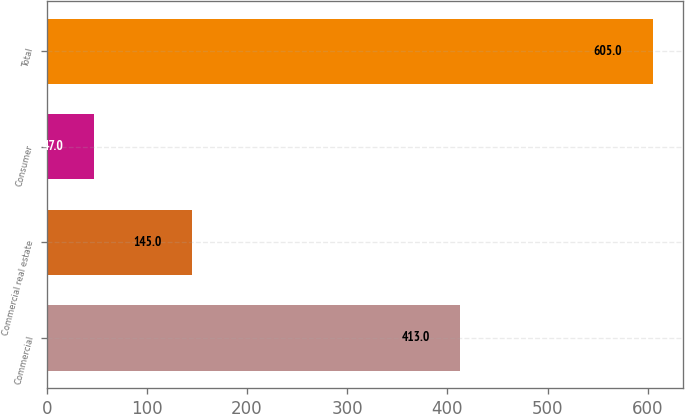<chart> <loc_0><loc_0><loc_500><loc_500><bar_chart><fcel>Commercial<fcel>Commercial real estate<fcel>Consumer<fcel>Total<nl><fcel>413<fcel>145<fcel>47<fcel>605<nl></chart> 